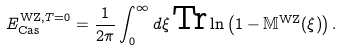Convert formula to latex. <formula><loc_0><loc_0><loc_500><loc_500>E _ { \text {Cas} } ^ { \text {WZ} , T = 0 } = \frac { 1 } { 2 \pi } \int _ { 0 } ^ { \infty } d \xi \, \text {Tr} \ln \left ( 1 - \mathbb { M } ^ { \text {WZ} } ( \xi ) \right ) .</formula> 